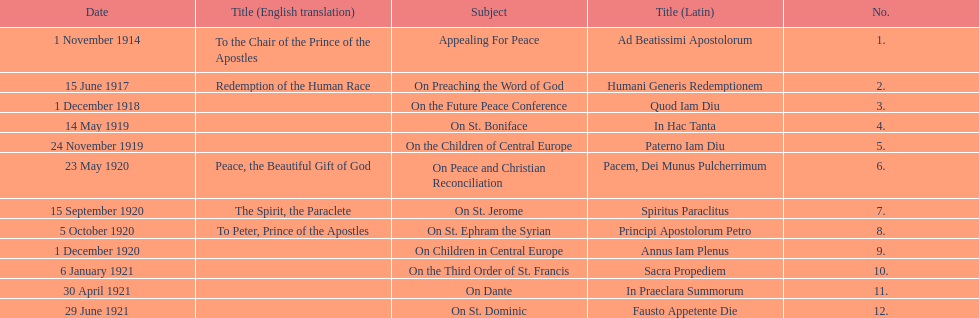How many titles are listed in the table? 12. 